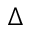Convert formula to latex. <formula><loc_0><loc_0><loc_500><loc_500>\Delta</formula> 